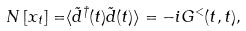Convert formula to latex. <formula><loc_0><loc_0><loc_500><loc_500>N \left [ x _ { t } \right ] = & \langle \tilde { d } ^ { \dag } ( t ) \tilde { d } ( t ) \rangle = - i G ^ { < } ( t , t ) ,</formula> 